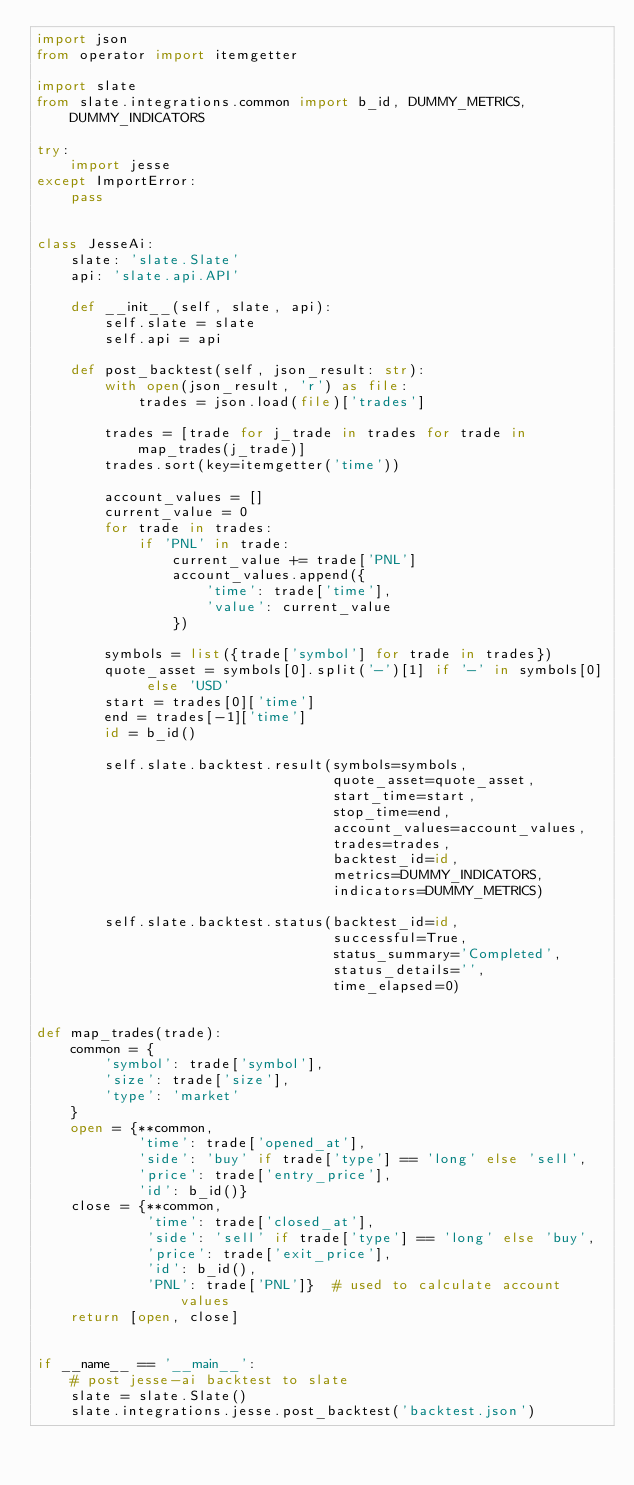Convert code to text. <code><loc_0><loc_0><loc_500><loc_500><_Python_>import json
from operator import itemgetter

import slate
from slate.integrations.common import b_id, DUMMY_METRICS, DUMMY_INDICATORS

try:
    import jesse
except ImportError:
    pass


class JesseAi:
    slate: 'slate.Slate'
    api: 'slate.api.API'

    def __init__(self, slate, api):
        self.slate = slate
        self.api = api

    def post_backtest(self, json_result: str):
        with open(json_result, 'r') as file:
            trades = json.load(file)['trades']

        trades = [trade for j_trade in trades for trade in map_trades(j_trade)]
        trades.sort(key=itemgetter('time'))

        account_values = []
        current_value = 0
        for trade in trades:
            if 'PNL' in trade:
                current_value += trade['PNL']
                account_values.append({
                    'time': trade['time'],
                    'value': current_value
                })

        symbols = list({trade['symbol'] for trade in trades})
        quote_asset = symbols[0].split('-')[1] if '-' in symbols[0] else 'USD'
        start = trades[0]['time']
        end = trades[-1]['time']
        id = b_id()

        self.slate.backtest.result(symbols=symbols,
                                   quote_asset=quote_asset,
                                   start_time=start,
                                   stop_time=end,
                                   account_values=account_values,
                                   trades=trades,
                                   backtest_id=id,
                                   metrics=DUMMY_INDICATORS,
                                   indicators=DUMMY_METRICS)

        self.slate.backtest.status(backtest_id=id,
                                   successful=True,
                                   status_summary='Completed',
                                   status_details='',
                                   time_elapsed=0)


def map_trades(trade):
    common = {
        'symbol': trade['symbol'],
        'size': trade['size'],
        'type': 'market'
    }
    open = {**common,
            'time': trade['opened_at'],
            'side': 'buy' if trade['type'] == 'long' else 'sell',
            'price': trade['entry_price'],
            'id': b_id()}
    close = {**common,
             'time': trade['closed_at'],
             'side': 'sell' if trade['type'] == 'long' else 'buy',
             'price': trade['exit_price'],
             'id': b_id(),
             'PNL': trade['PNL']}  # used to calculate account values
    return [open, close]


if __name__ == '__main__':
    # post jesse-ai backtest to slate
    slate = slate.Slate()
    slate.integrations.jesse.post_backtest('backtest.json')
</code> 